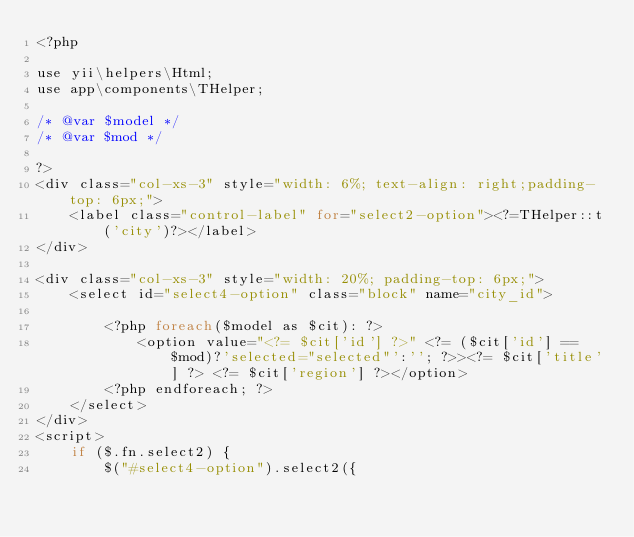<code> <loc_0><loc_0><loc_500><loc_500><_PHP_><?php

use yii\helpers\Html;
use app\components\THelper;

/* @var $model */
/* @var $mod */

?>
<div class="col-xs-3" style="width: 6%; text-align: right;padding-top: 6px;">
    <label class="control-label" for="select2-option"><?=THelper::t('city')?></label>
</div>

<div class="col-xs-3" style="width: 20%; padding-top: 6px;">
    <select id="select4-option" class="block" name="city_id">

        <?php foreach($model as $cit): ?>
            <option value="<?= $cit['id'] ?>" <?= ($cit['id'] == $mod)?'selected="selected"':''; ?>><?= $cit['title'] ?> <?= $cit['region'] ?></option>
        <?php endforeach; ?>
    </select>
</div>
<script>
    if ($.fn.select2) {
        $("#select4-option").select2({</code> 